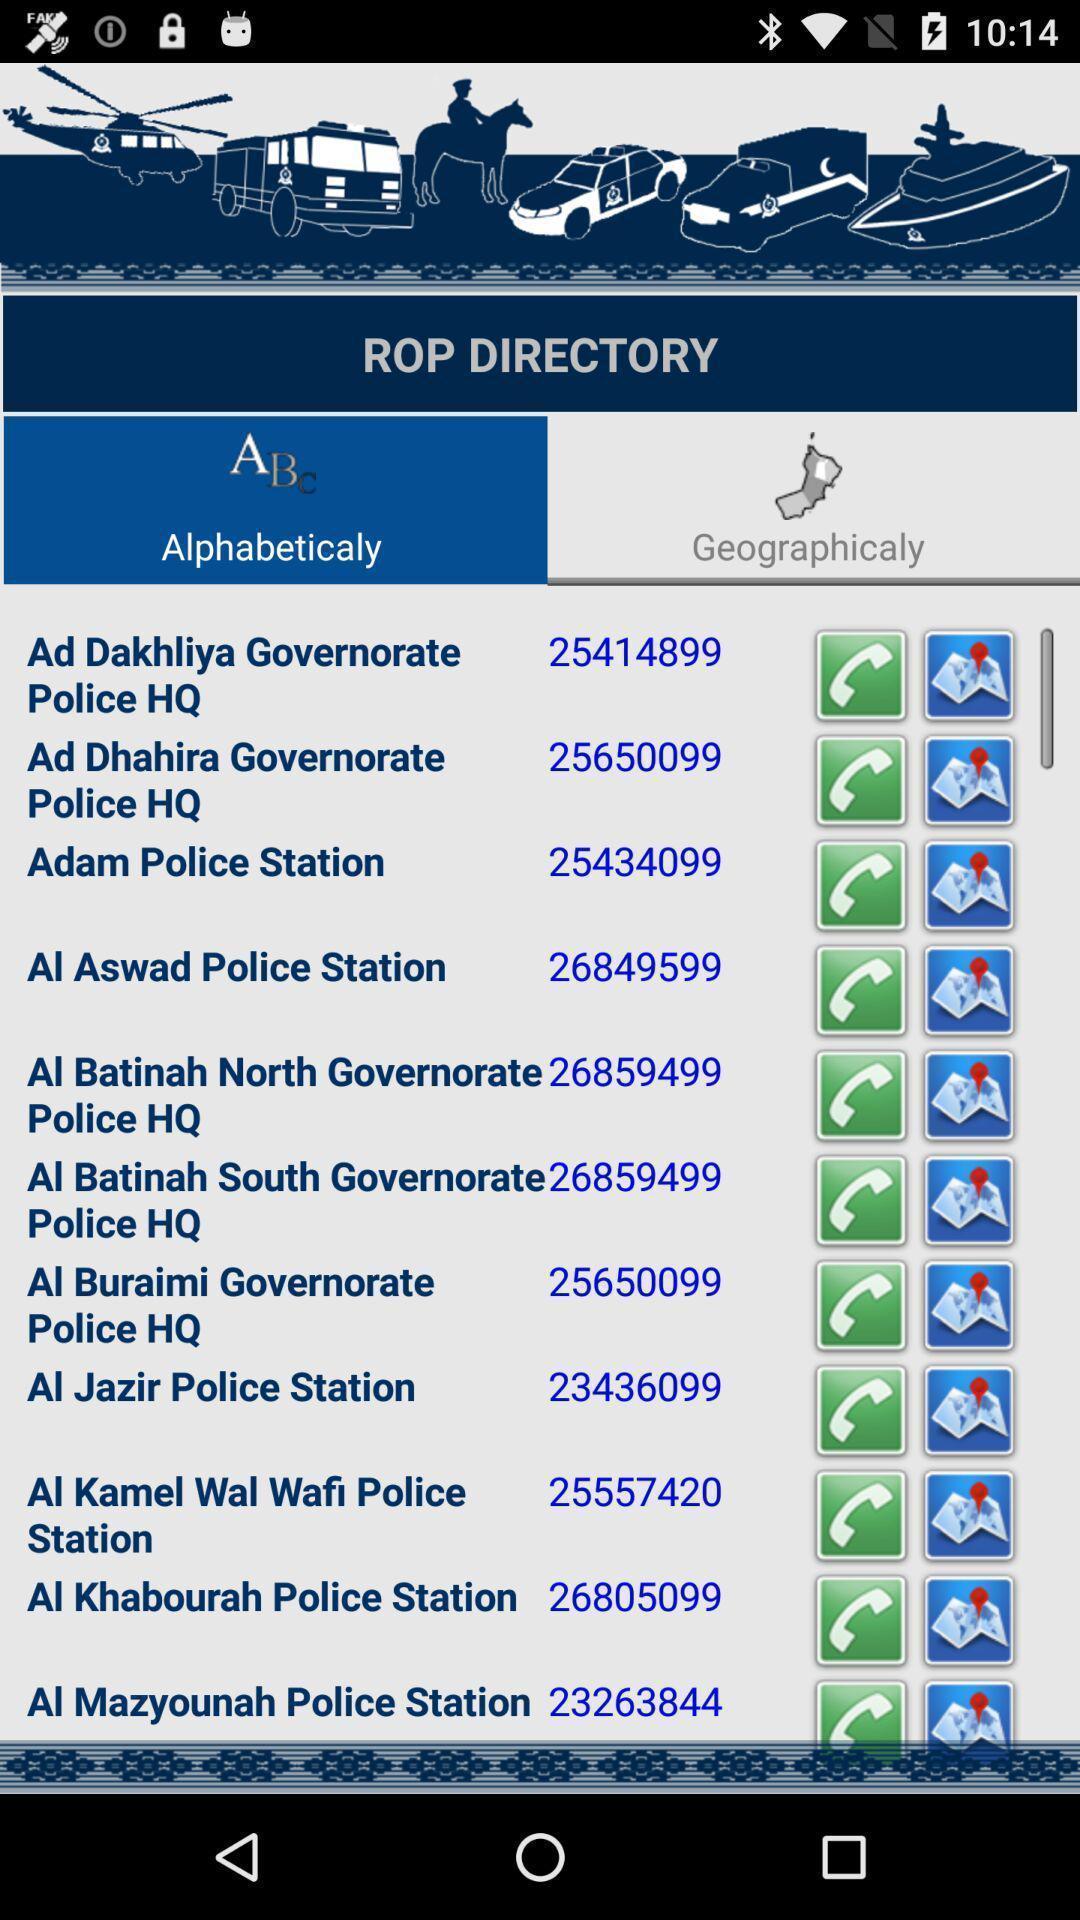Explain what's happening in this screen capture. Page displaying with list of contacts. 